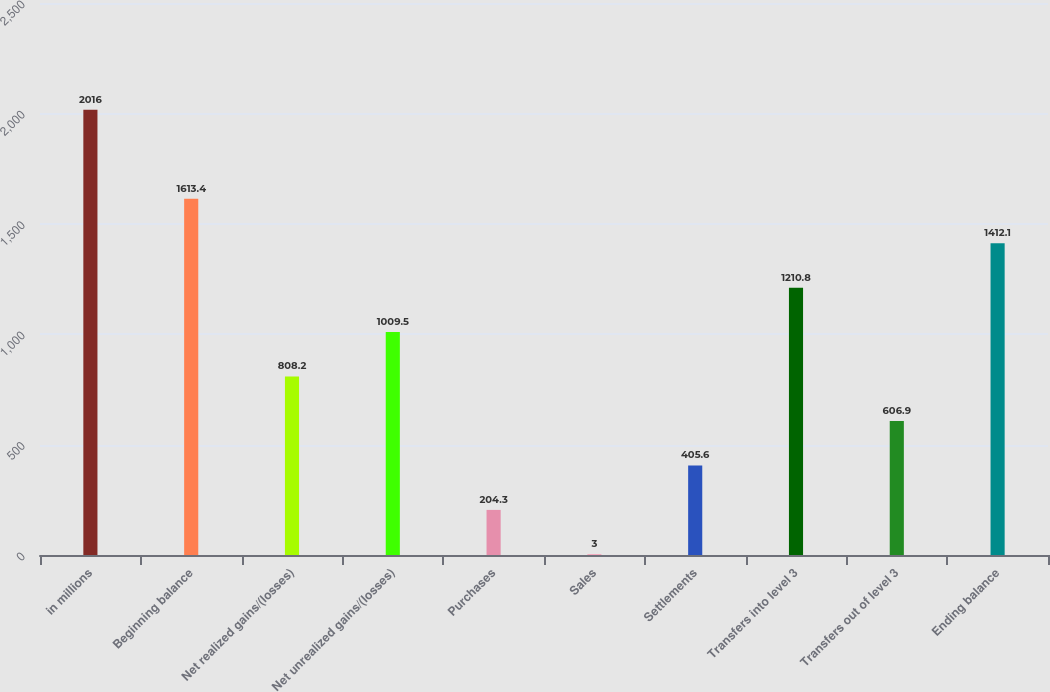Convert chart to OTSL. <chart><loc_0><loc_0><loc_500><loc_500><bar_chart><fcel>in millions<fcel>Beginning balance<fcel>Net realized gains/(losses)<fcel>Net unrealized gains/(losses)<fcel>Purchases<fcel>Sales<fcel>Settlements<fcel>Transfers into level 3<fcel>Transfers out of level 3<fcel>Ending balance<nl><fcel>2016<fcel>1613.4<fcel>808.2<fcel>1009.5<fcel>204.3<fcel>3<fcel>405.6<fcel>1210.8<fcel>606.9<fcel>1412.1<nl></chart> 